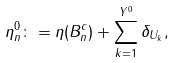Convert formula to latex. <formula><loc_0><loc_0><loc_500><loc_500>\eta _ { n } ^ { 0 } \colon = \eta ( B _ { n } ^ { c } ) + \sum _ { k = 1 } ^ { Y ^ { 0 } } \delta _ { U _ { k } } ,</formula> 